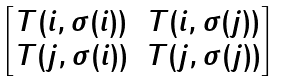<formula> <loc_0><loc_0><loc_500><loc_500>\begin{bmatrix} T ( i , \sigma ( i ) ) & T ( i , \sigma ( j ) ) \\ T ( j , \sigma ( i ) ) & T ( j , \sigma ( j ) ) \end{bmatrix}</formula> 